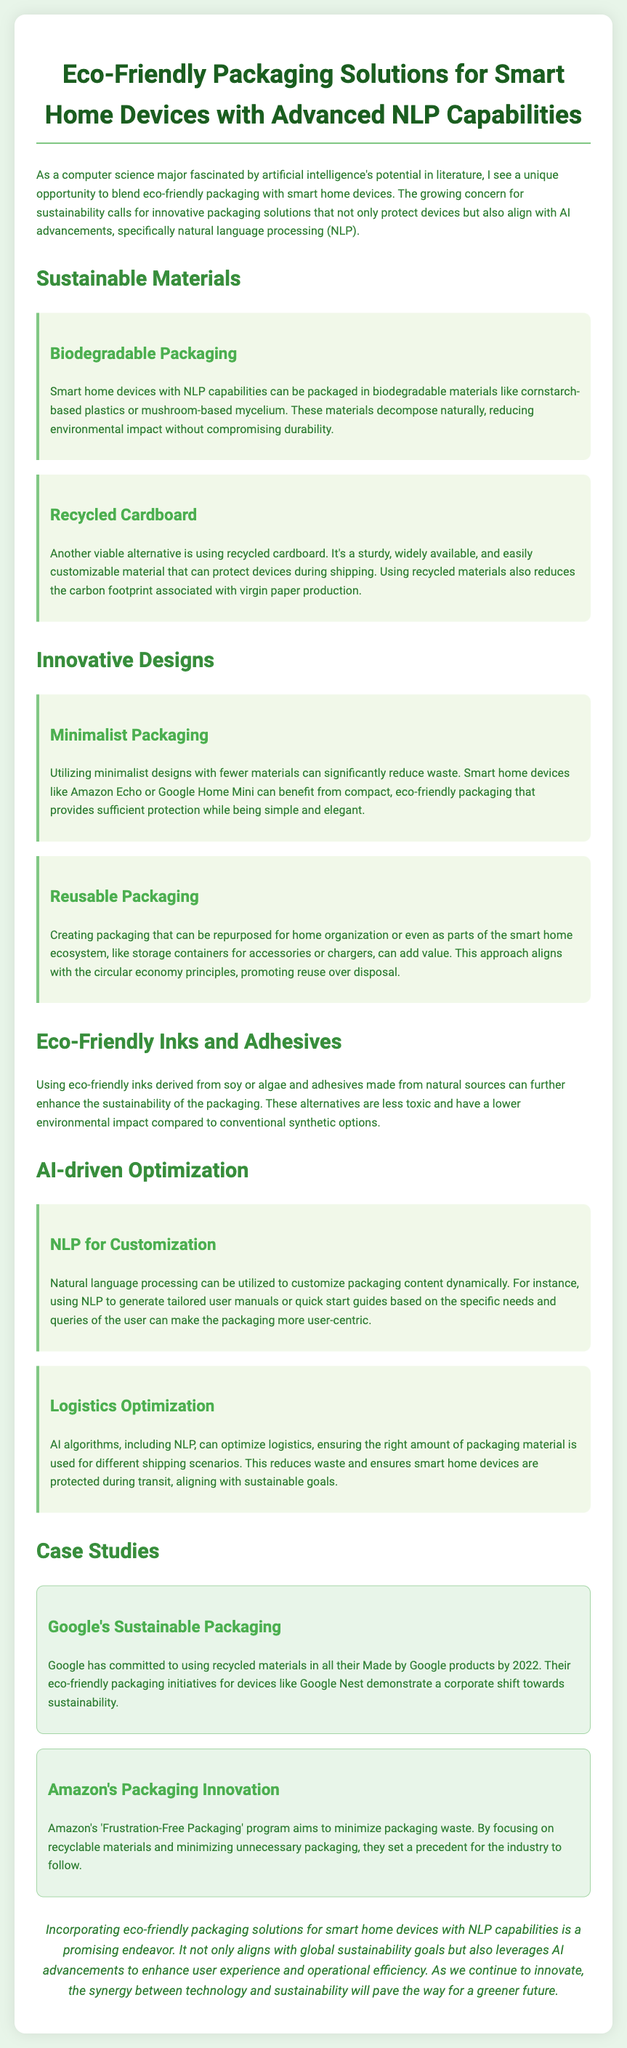what packaging material is mentioned for biodegradability? The document highlights materials such as cornstarch-based plastics and mushroom-based mycelium as biodegradable options for packaging.
Answer: cornstarch-based plastics or mushroom-based mycelium what is the benefit of using recycled cardboard? The document states that recycled cardboard is sturdy, widely available, and reduces the carbon footprint associated with virgin paper production.
Answer: reduces carbon footprint how does minimalist packaging contribute to sustainability? The document explains that minimalist designs with fewer materials can significantly reduce waste, benefiting the packaging of smart home devices.
Answer: reduce waste what types of eco-friendly inks are suggested? The document suggests using eco-friendly inks derived from soy or algae for packaging.
Answer: soy or algae which company committed to using recycled materials by 2022? The document mentions Google's commitment to using recycled materials in their Made by Google products.
Answer: Google how does NLP enhance packaging customization? The document states that NLP can generate tailored user manuals or quick start guides based on user needs.
Answer: tailored user manuals what is the focus of Amazon's 'Frustration-Free Packaging' program? The document indicates that Amazon's program aims to minimize packaging waste and emphasizes recyclable materials.
Answer: minimize packaging waste what is a potential use for reusable packaging? The document describes that reusable packaging can be repurposed for home organization or as part of the smart home ecosystem.
Answer: home organization what two eco-friendly packaging initiatives are mentioned in case studies? The document outlines Google's sustainable packaging and Amazon's packaging innovation as case studies.
Answer: Google's sustainable packaging and Amazon's packaging innovation 